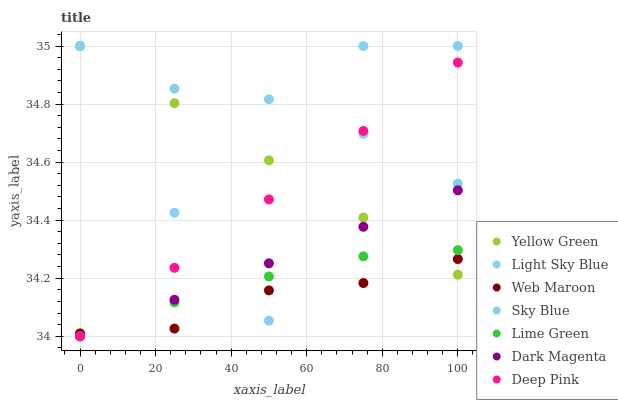Does Web Maroon have the minimum area under the curve?
Answer yes or no. Yes. Does Sky Blue have the maximum area under the curve?
Answer yes or no. Yes. Does Yellow Green have the minimum area under the curve?
Answer yes or no. No. Does Yellow Green have the maximum area under the curve?
Answer yes or no. No. Is Yellow Green the smoothest?
Answer yes or no. Yes. Is Light Sky Blue the roughest?
Answer yes or no. Yes. Is Web Maroon the smoothest?
Answer yes or no. No. Is Web Maroon the roughest?
Answer yes or no. No. Does Deep Pink have the lowest value?
Answer yes or no. Yes. Does Yellow Green have the lowest value?
Answer yes or no. No. Does Sky Blue have the highest value?
Answer yes or no. Yes. Does Web Maroon have the highest value?
Answer yes or no. No. Is Web Maroon less than Sky Blue?
Answer yes or no. Yes. Is Sky Blue greater than Web Maroon?
Answer yes or no. Yes. Does Deep Pink intersect Sky Blue?
Answer yes or no. Yes. Is Deep Pink less than Sky Blue?
Answer yes or no. No. Is Deep Pink greater than Sky Blue?
Answer yes or no. No. Does Web Maroon intersect Sky Blue?
Answer yes or no. No. 